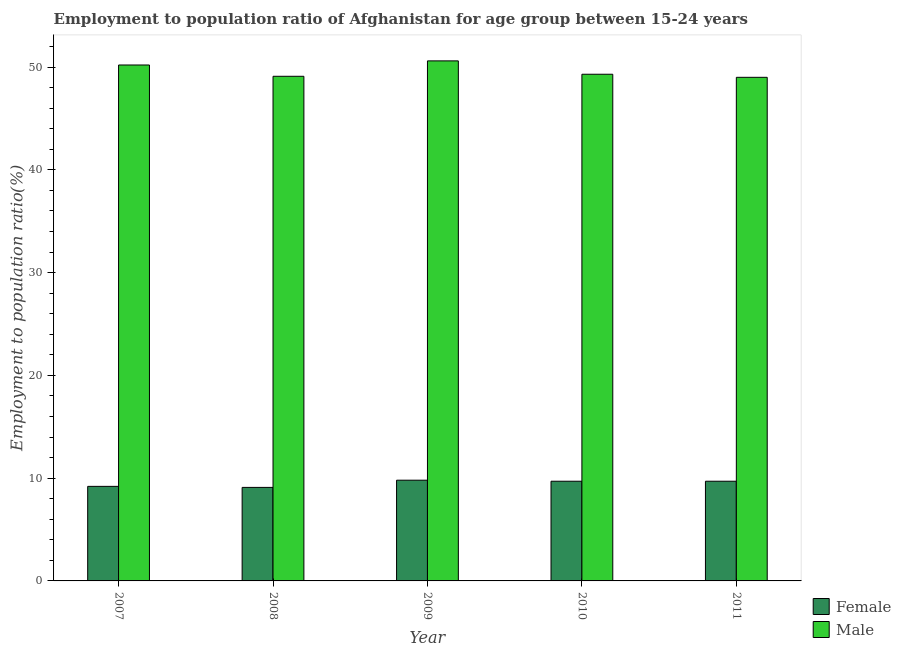How many groups of bars are there?
Ensure brevity in your answer.  5. Are the number of bars per tick equal to the number of legend labels?
Your answer should be compact. Yes. How many bars are there on the 4th tick from the left?
Provide a short and direct response. 2. How many bars are there on the 2nd tick from the right?
Make the answer very short. 2. In how many cases, is the number of bars for a given year not equal to the number of legend labels?
Your answer should be very brief. 0. What is the employment to population ratio(male) in 2009?
Your answer should be very brief. 50.6. Across all years, what is the maximum employment to population ratio(female)?
Offer a terse response. 9.8. In which year was the employment to population ratio(female) maximum?
Your answer should be compact. 2009. What is the total employment to population ratio(female) in the graph?
Make the answer very short. 47.5. What is the difference between the employment to population ratio(female) in 2007 and that in 2008?
Your answer should be compact. 0.1. What is the difference between the employment to population ratio(female) in 2010 and the employment to population ratio(male) in 2007?
Ensure brevity in your answer.  0.5. What is the average employment to population ratio(male) per year?
Provide a succinct answer. 49.64. In how many years, is the employment to population ratio(female) greater than 26 %?
Your response must be concise. 0. What is the ratio of the employment to population ratio(male) in 2008 to that in 2010?
Your answer should be very brief. 1. Is the employment to population ratio(male) in 2009 less than that in 2011?
Make the answer very short. No. What is the difference between the highest and the second highest employment to population ratio(male)?
Your answer should be very brief. 0.4. What is the difference between the highest and the lowest employment to population ratio(male)?
Provide a short and direct response. 1.6. What does the 1st bar from the left in 2007 represents?
Ensure brevity in your answer.  Female. What does the 2nd bar from the right in 2009 represents?
Give a very brief answer. Female. How many bars are there?
Give a very brief answer. 10. Are the values on the major ticks of Y-axis written in scientific E-notation?
Your answer should be very brief. No. Does the graph contain any zero values?
Offer a very short reply. No. Does the graph contain grids?
Give a very brief answer. No. Where does the legend appear in the graph?
Give a very brief answer. Bottom right. How many legend labels are there?
Keep it short and to the point. 2. How are the legend labels stacked?
Your answer should be compact. Vertical. What is the title of the graph?
Provide a succinct answer. Employment to population ratio of Afghanistan for age group between 15-24 years. What is the Employment to population ratio(%) of Female in 2007?
Offer a terse response. 9.2. What is the Employment to population ratio(%) of Male in 2007?
Ensure brevity in your answer.  50.2. What is the Employment to population ratio(%) of Female in 2008?
Make the answer very short. 9.1. What is the Employment to population ratio(%) of Male in 2008?
Offer a terse response. 49.1. What is the Employment to population ratio(%) in Female in 2009?
Keep it short and to the point. 9.8. What is the Employment to population ratio(%) in Male in 2009?
Keep it short and to the point. 50.6. What is the Employment to population ratio(%) in Female in 2010?
Offer a terse response. 9.7. What is the Employment to population ratio(%) in Male in 2010?
Your response must be concise. 49.3. What is the Employment to population ratio(%) in Female in 2011?
Your answer should be compact. 9.7. What is the Employment to population ratio(%) of Male in 2011?
Make the answer very short. 49. Across all years, what is the maximum Employment to population ratio(%) in Female?
Offer a terse response. 9.8. Across all years, what is the maximum Employment to population ratio(%) in Male?
Offer a very short reply. 50.6. Across all years, what is the minimum Employment to population ratio(%) in Female?
Keep it short and to the point. 9.1. Across all years, what is the minimum Employment to population ratio(%) of Male?
Provide a succinct answer. 49. What is the total Employment to population ratio(%) of Female in the graph?
Provide a succinct answer. 47.5. What is the total Employment to population ratio(%) of Male in the graph?
Your answer should be compact. 248.2. What is the difference between the Employment to population ratio(%) of Female in 2007 and that in 2008?
Offer a very short reply. 0.1. What is the difference between the Employment to population ratio(%) of Male in 2007 and that in 2009?
Ensure brevity in your answer.  -0.4. What is the difference between the Employment to population ratio(%) of Male in 2007 and that in 2010?
Offer a terse response. 0.9. What is the difference between the Employment to population ratio(%) of Female in 2007 and that in 2011?
Your answer should be compact. -0.5. What is the difference between the Employment to population ratio(%) of Male in 2007 and that in 2011?
Ensure brevity in your answer.  1.2. What is the difference between the Employment to population ratio(%) of Female in 2008 and that in 2010?
Keep it short and to the point. -0.6. What is the difference between the Employment to population ratio(%) in Female in 2009 and that in 2010?
Your answer should be very brief. 0.1. What is the difference between the Employment to population ratio(%) of Male in 2009 and that in 2010?
Make the answer very short. 1.3. What is the difference between the Employment to population ratio(%) of Male in 2010 and that in 2011?
Provide a short and direct response. 0.3. What is the difference between the Employment to population ratio(%) of Female in 2007 and the Employment to population ratio(%) of Male in 2008?
Your answer should be compact. -39.9. What is the difference between the Employment to population ratio(%) of Female in 2007 and the Employment to population ratio(%) of Male in 2009?
Give a very brief answer. -41.4. What is the difference between the Employment to population ratio(%) in Female in 2007 and the Employment to population ratio(%) in Male in 2010?
Keep it short and to the point. -40.1. What is the difference between the Employment to population ratio(%) of Female in 2007 and the Employment to population ratio(%) of Male in 2011?
Offer a very short reply. -39.8. What is the difference between the Employment to population ratio(%) in Female in 2008 and the Employment to population ratio(%) in Male in 2009?
Make the answer very short. -41.5. What is the difference between the Employment to population ratio(%) in Female in 2008 and the Employment to population ratio(%) in Male in 2010?
Your answer should be very brief. -40.2. What is the difference between the Employment to population ratio(%) of Female in 2008 and the Employment to population ratio(%) of Male in 2011?
Offer a very short reply. -39.9. What is the difference between the Employment to population ratio(%) of Female in 2009 and the Employment to population ratio(%) of Male in 2010?
Your answer should be very brief. -39.5. What is the difference between the Employment to population ratio(%) of Female in 2009 and the Employment to population ratio(%) of Male in 2011?
Make the answer very short. -39.2. What is the difference between the Employment to population ratio(%) of Female in 2010 and the Employment to population ratio(%) of Male in 2011?
Provide a succinct answer. -39.3. What is the average Employment to population ratio(%) of Male per year?
Ensure brevity in your answer.  49.64. In the year 2007, what is the difference between the Employment to population ratio(%) in Female and Employment to population ratio(%) in Male?
Offer a very short reply. -41. In the year 2008, what is the difference between the Employment to population ratio(%) of Female and Employment to population ratio(%) of Male?
Keep it short and to the point. -40. In the year 2009, what is the difference between the Employment to population ratio(%) in Female and Employment to population ratio(%) in Male?
Make the answer very short. -40.8. In the year 2010, what is the difference between the Employment to population ratio(%) in Female and Employment to population ratio(%) in Male?
Ensure brevity in your answer.  -39.6. In the year 2011, what is the difference between the Employment to population ratio(%) in Female and Employment to population ratio(%) in Male?
Offer a terse response. -39.3. What is the ratio of the Employment to population ratio(%) of Male in 2007 to that in 2008?
Your answer should be very brief. 1.02. What is the ratio of the Employment to population ratio(%) of Female in 2007 to that in 2009?
Offer a terse response. 0.94. What is the ratio of the Employment to population ratio(%) of Female in 2007 to that in 2010?
Your response must be concise. 0.95. What is the ratio of the Employment to population ratio(%) in Male in 2007 to that in 2010?
Provide a short and direct response. 1.02. What is the ratio of the Employment to population ratio(%) in Female in 2007 to that in 2011?
Offer a very short reply. 0.95. What is the ratio of the Employment to population ratio(%) of Male in 2007 to that in 2011?
Ensure brevity in your answer.  1.02. What is the ratio of the Employment to population ratio(%) in Male in 2008 to that in 2009?
Make the answer very short. 0.97. What is the ratio of the Employment to population ratio(%) in Female in 2008 to that in 2010?
Keep it short and to the point. 0.94. What is the ratio of the Employment to population ratio(%) in Female in 2008 to that in 2011?
Provide a short and direct response. 0.94. What is the ratio of the Employment to population ratio(%) of Female in 2009 to that in 2010?
Give a very brief answer. 1.01. What is the ratio of the Employment to population ratio(%) in Male in 2009 to that in 2010?
Your answer should be compact. 1.03. What is the ratio of the Employment to population ratio(%) in Female in 2009 to that in 2011?
Provide a short and direct response. 1.01. What is the ratio of the Employment to population ratio(%) in Male in 2009 to that in 2011?
Keep it short and to the point. 1.03. What is the ratio of the Employment to population ratio(%) of Female in 2010 to that in 2011?
Your answer should be compact. 1. What is the difference between the highest and the second highest Employment to population ratio(%) of Female?
Make the answer very short. 0.1. What is the difference between the highest and the second highest Employment to population ratio(%) in Male?
Your answer should be compact. 0.4. 